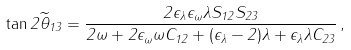<formula> <loc_0><loc_0><loc_500><loc_500>\tan 2 \widetilde { \theta } _ { 1 3 } = \frac { 2 \epsilon _ { \lambda } \epsilon _ { \omega } \lambda S _ { 1 2 } S _ { 2 3 } } { 2 \omega + 2 \epsilon _ { \omega } \omega C _ { 1 2 } + ( \epsilon _ { \lambda } - 2 ) \lambda + \epsilon _ { \lambda } \lambda C _ { 2 3 } } \, ,</formula> 